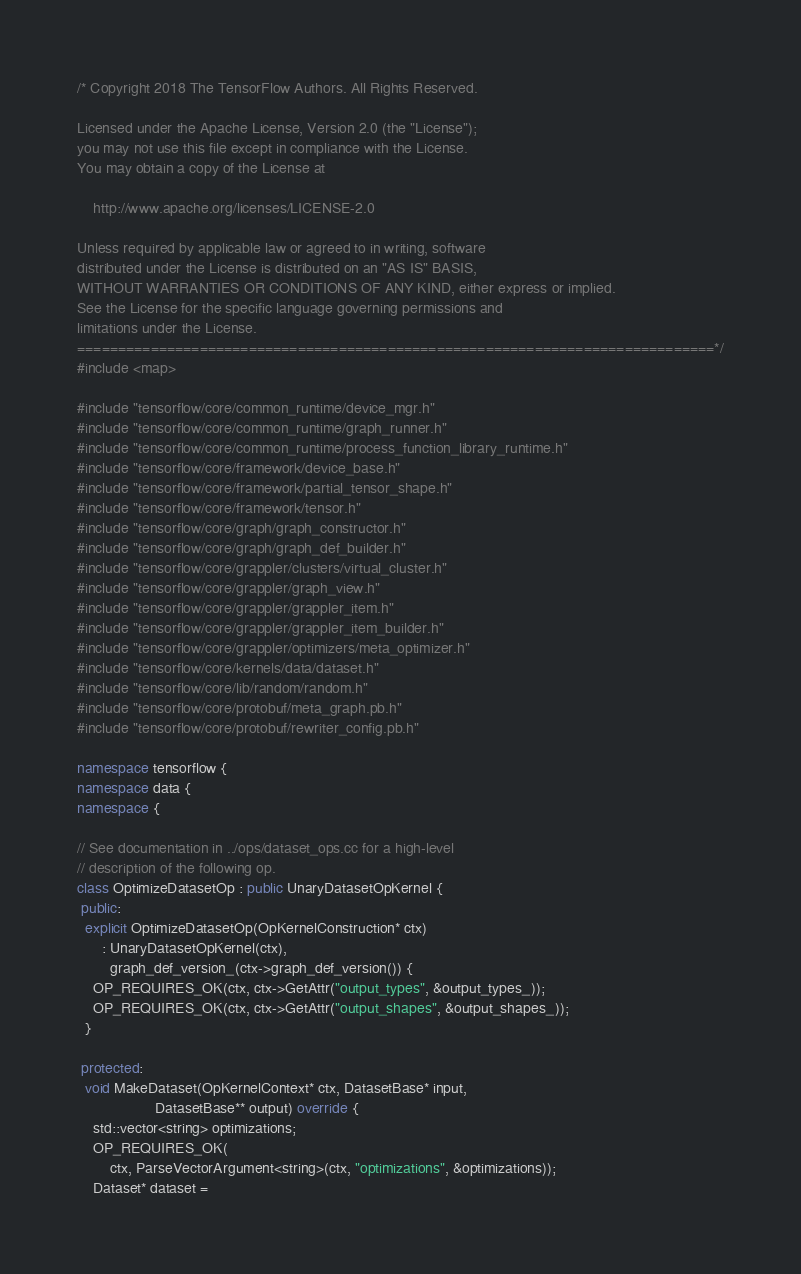<code> <loc_0><loc_0><loc_500><loc_500><_C++_>/* Copyright 2018 The TensorFlow Authors. All Rights Reserved.

Licensed under the Apache License, Version 2.0 (the "License");
you may not use this file except in compliance with the License.
You may obtain a copy of the License at

    http://www.apache.org/licenses/LICENSE-2.0

Unless required by applicable law or agreed to in writing, software
distributed under the License is distributed on an "AS IS" BASIS,
WITHOUT WARRANTIES OR CONDITIONS OF ANY KIND, either express or implied.
See the License for the specific language governing permissions and
limitations under the License.
==============================================================================*/
#include <map>

#include "tensorflow/core/common_runtime/device_mgr.h"
#include "tensorflow/core/common_runtime/graph_runner.h"
#include "tensorflow/core/common_runtime/process_function_library_runtime.h"
#include "tensorflow/core/framework/device_base.h"
#include "tensorflow/core/framework/partial_tensor_shape.h"
#include "tensorflow/core/framework/tensor.h"
#include "tensorflow/core/graph/graph_constructor.h"
#include "tensorflow/core/graph/graph_def_builder.h"
#include "tensorflow/core/grappler/clusters/virtual_cluster.h"
#include "tensorflow/core/grappler/graph_view.h"
#include "tensorflow/core/grappler/grappler_item.h"
#include "tensorflow/core/grappler/grappler_item_builder.h"
#include "tensorflow/core/grappler/optimizers/meta_optimizer.h"
#include "tensorflow/core/kernels/data/dataset.h"
#include "tensorflow/core/lib/random/random.h"
#include "tensorflow/core/protobuf/meta_graph.pb.h"
#include "tensorflow/core/protobuf/rewriter_config.pb.h"

namespace tensorflow {
namespace data {
namespace {

// See documentation in ../ops/dataset_ops.cc for a high-level
// description of the following op.
class OptimizeDatasetOp : public UnaryDatasetOpKernel {
 public:
  explicit OptimizeDatasetOp(OpKernelConstruction* ctx)
      : UnaryDatasetOpKernel(ctx),
        graph_def_version_(ctx->graph_def_version()) {
    OP_REQUIRES_OK(ctx, ctx->GetAttr("output_types", &output_types_));
    OP_REQUIRES_OK(ctx, ctx->GetAttr("output_shapes", &output_shapes_));
  }

 protected:
  void MakeDataset(OpKernelContext* ctx, DatasetBase* input,
                   DatasetBase** output) override {
    std::vector<string> optimizations;
    OP_REQUIRES_OK(
        ctx, ParseVectorArgument<string>(ctx, "optimizations", &optimizations));
    Dataset* dataset =</code> 